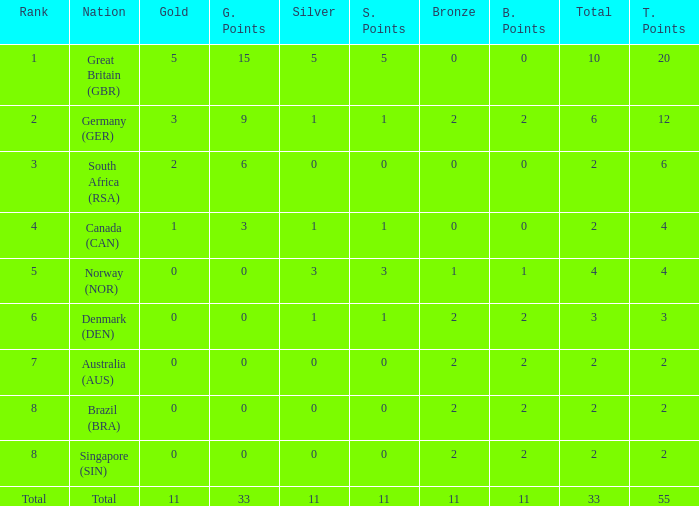Parse the full table. {'header': ['Rank', 'Nation', 'Gold', 'G. Points', 'Silver', 'S. Points', 'Bronze', 'B. Points', 'Total', 'T. Points'], 'rows': [['1', 'Great Britain (GBR)', '5', '15', '5', '5', '0', '0', '10', '20'], ['2', 'Germany (GER)', '3', '9', '1', '1', '2', '2', '6', '12'], ['3', 'South Africa (RSA)', '2', '6', '0', '0', '0', '0', '2', '6'], ['4', 'Canada (CAN)', '1', '3', '1', '1', '0', '0', '2', '4'], ['5', 'Norway (NOR)', '0', '0', '3', '3', '1', '1', '4', '4'], ['6', 'Denmark (DEN)', '0', '0', '1', '1', '2', '2', '3', '3'], ['7', 'Australia (AUS)', '0', '0', '0', '0', '2', '2', '2', '2'], ['8', 'Brazil (BRA)', '0', '0', '0', '0', '2', '2', '2', '2'], ['8', 'Singapore (SIN)', '0', '0', '0', '0', '2', '2', '2', '2'], ['Total', 'Total', '11', '33', '11', '11', '11', '11', '33', '55']]} What is the total when the nation is brazil (bra) and bronze is more than 2? None. 